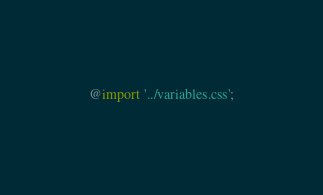Convert code to text. <code><loc_0><loc_0><loc_500><loc_500><_CSS_>@import '../variables.css';
</code> 